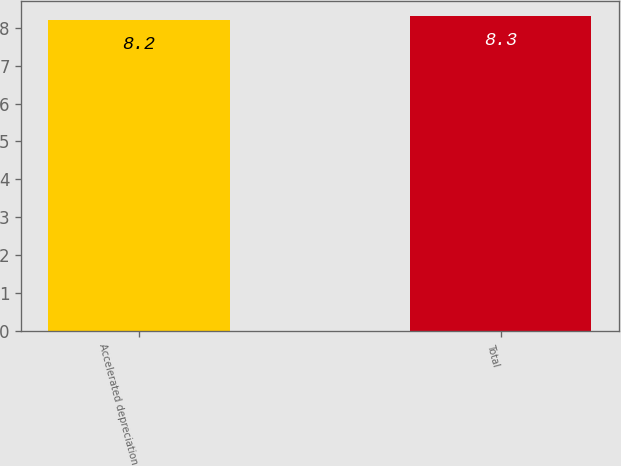Convert chart to OTSL. <chart><loc_0><loc_0><loc_500><loc_500><bar_chart><fcel>Accelerated depreciation<fcel>Total<nl><fcel>8.2<fcel>8.3<nl></chart> 